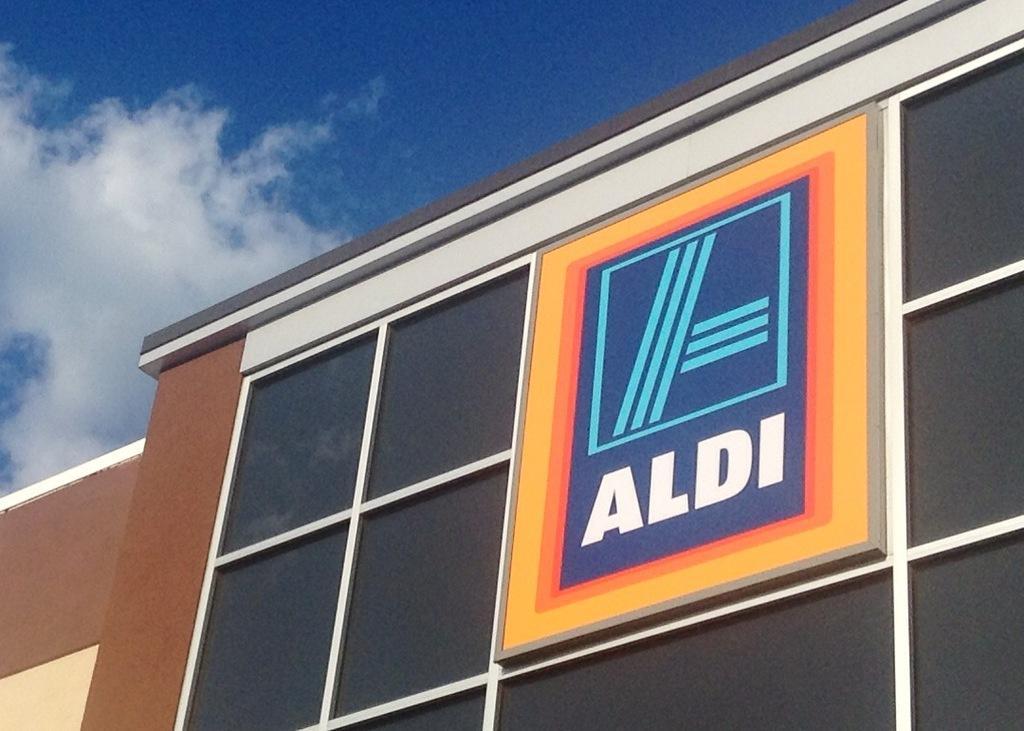How would you summarize this image in a sentence or two? In the image there is a building and in front of the building there is a logo and under the logo there is some name. 